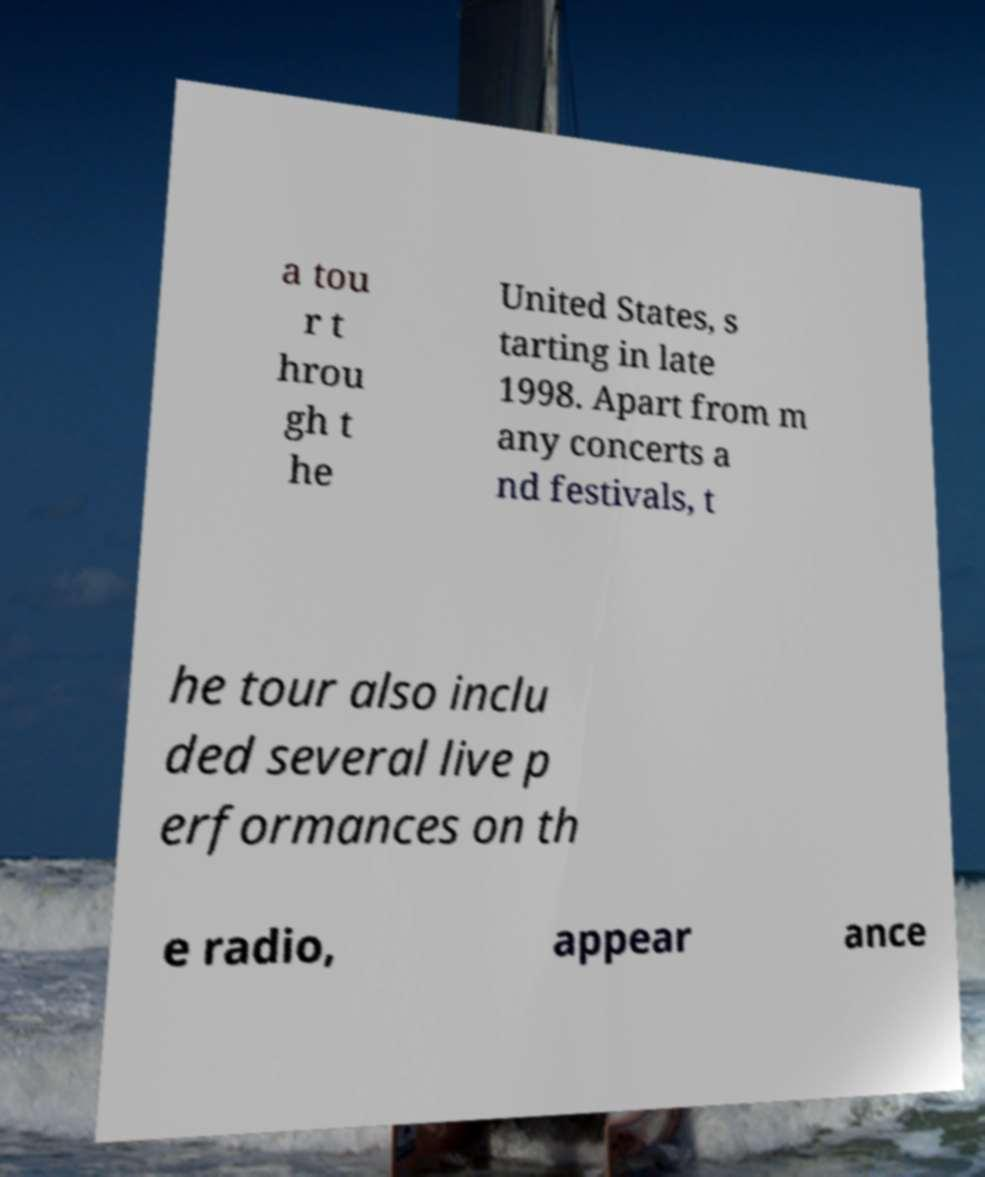There's text embedded in this image that I need extracted. Can you transcribe it verbatim? a tou r t hrou gh t he United States, s tarting in late 1998. Apart from m any concerts a nd festivals, t he tour also inclu ded several live p erformances on th e radio, appear ance 